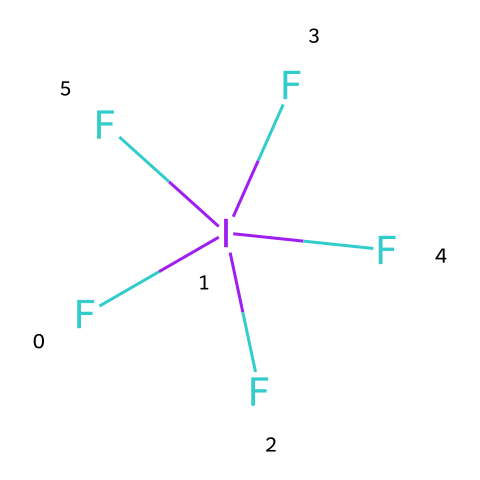How many atoms are present in iodine pentafluoride? The chemical consists of one iodine atom and five fluorine atoms, totaling six atoms overall.
Answer: six What is the central atom in this Lewis structure? In the Lewis structure, iodine is the central atom surrounded by the five fluorine atoms.
Answer: iodine How many bonds are formed between iodine and fluorine in this compound? Each fluorine atom is bonded to the iodine atom, resulting in five single bonds in total.
Answer: five What type of hybridization is suggested for the iodine atom in this molecule? The iodine atom in iodine pentafluoride exhibits sp3d hybridization due to the presence of five bonding pairs and no lone pairs.
Answer: sp3d Why is iodine able to exceed the octet rule in this compound? Iodine can accommodate more than eight electrons because it has available d-orbitals that allow for the formation of five bonds, leading to hypervalency.
Answer: hypervalency What is the molecular shape of iodine pentafluoride according to VSEPR theory? According to VSEPR theory, the molecular shape with five fluorine atoms around the iodine would result in a trigonal bipyramidal geometry.
Answer: trigonal bipyramidal How many lone pairs of electrons are present on the iodine atom in this structure? The iodine atom in iodine pentafluoride has no lone pairs of electrons, as all of its available valence electrons are involved in bonding with fluorine.
Answer: zero 